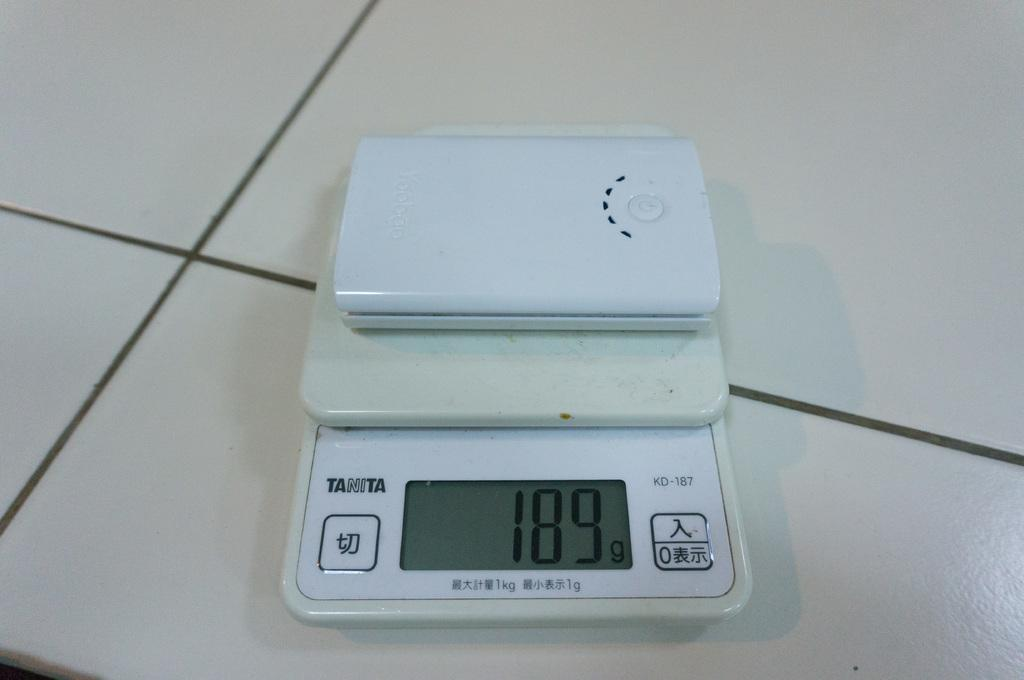What type of weighing machine is in the image? There is a kitchen weighing machine in the image. Where is the kitchen weighing machine located? The kitchen weighing machine is placed on a surface. How many horses are visible in the image? There are no horses present in the image. What type of fowl can be seen interacting with the kitchen weighing machine in the image? There is no fowl present in the image; only the kitchen weighing machine is visible. 